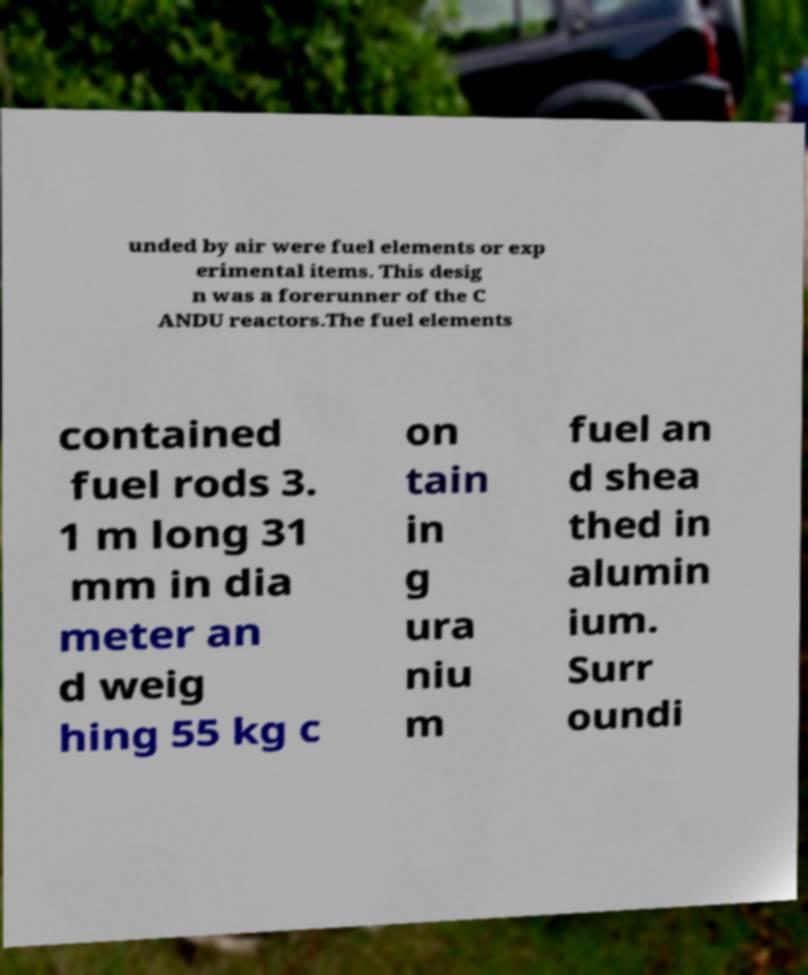Can you accurately transcribe the text from the provided image for me? unded by air were fuel elements or exp erimental items. This desig n was a forerunner of the C ANDU reactors.The fuel elements contained fuel rods 3. 1 m long 31 mm in dia meter an d weig hing 55 kg c on tain in g ura niu m fuel an d shea thed in alumin ium. Surr oundi 